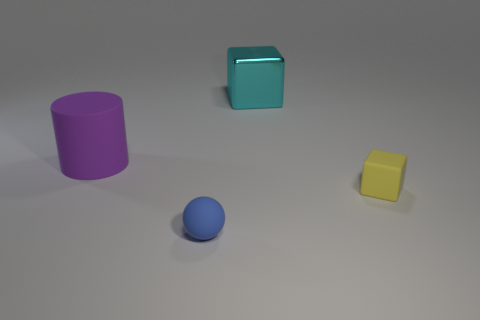Add 1 large cubes. How many objects exist? 5 Subtract all balls. How many objects are left? 3 Add 4 yellow rubber objects. How many yellow rubber objects are left? 5 Add 4 small matte balls. How many small matte balls exist? 5 Subtract 0 purple cubes. How many objects are left? 4 Subtract all tiny yellow cubes. Subtract all small cyan rubber cylinders. How many objects are left? 3 